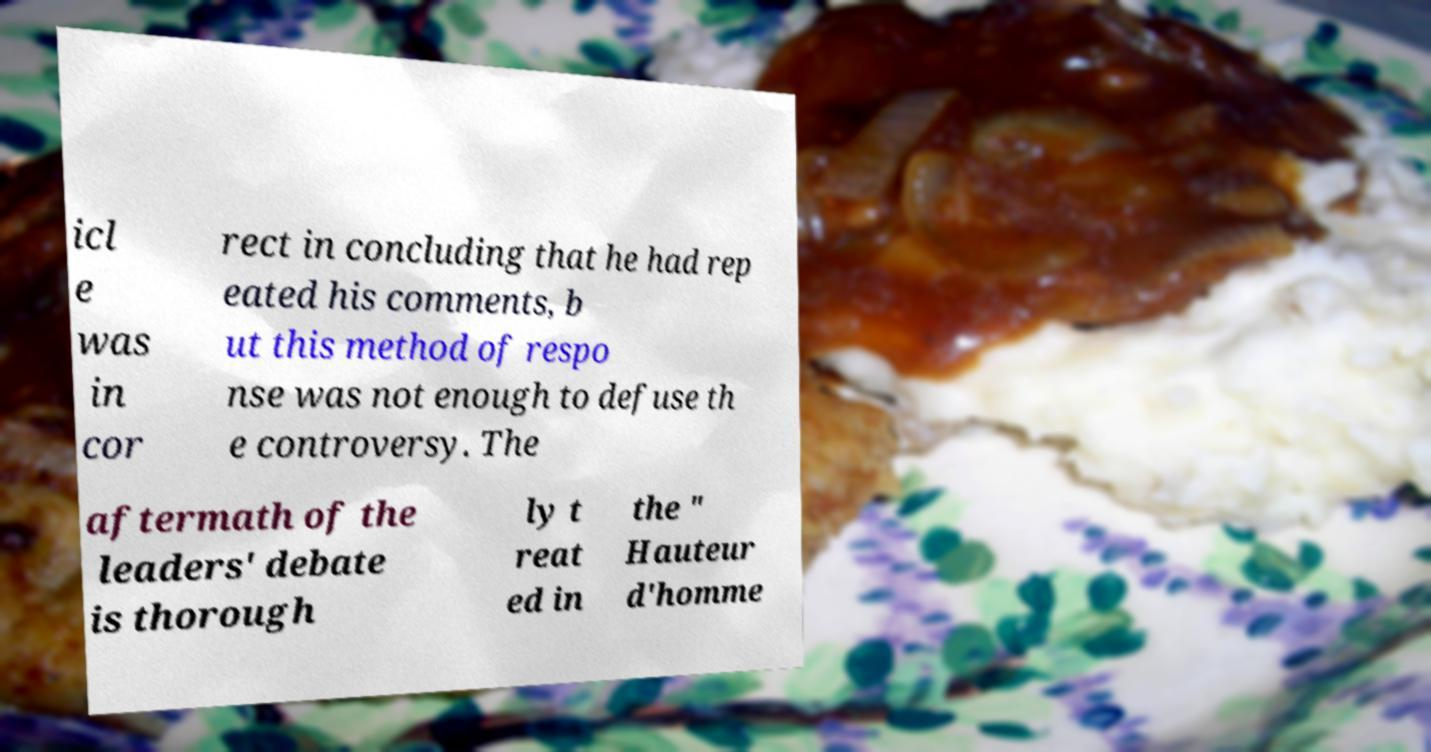I need the written content from this picture converted into text. Can you do that? icl e was in cor rect in concluding that he had rep eated his comments, b ut this method of respo nse was not enough to defuse th e controversy. The aftermath of the leaders' debate is thorough ly t reat ed in the " Hauteur d'homme 